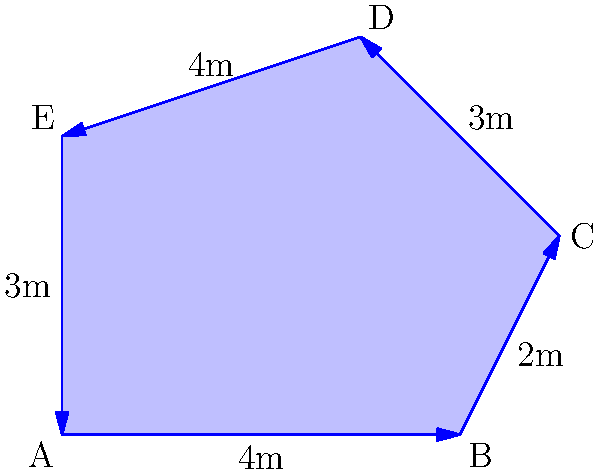The Bayleigh Chase grounds feature an irregularly shaped pond as shown in the diagram. The pond's perimeter is formed by five straight edges with lengths of 4m, 2m, 3m, 4m, and 3m. What is the area of this pond in square meters? To find the area of this irregular polygon, we can use the following steps:

1. Divide the polygon into triangles.
2. Calculate the area of each triangle.
3. Sum up the areas of all triangles.

Let's divide the polygon into three triangles: ABC, ACD, and ADE.

For triangle ABC:
Base = 4m, Height = 2m
Area of ABC = $\frac{1}{2} \times 4 \times 2 = 4$ sq m

For triangle ACD:
We can use Heron's formula: $A = \sqrt{s(s-a)(s-b)(s-c)}$
where $s = \frac{a+b+c}{2}$ (semi-perimeter)
$a = 4$, $b = 3$, $c = 5$ (using Pythagorean theorem for AC)
$s = \frac{4+3+5}{2} = 6$
Area of ACD = $\sqrt{6(6-4)(6-3)(6-5)} = \sqrt{6 \times 2 \times 3 \times 1} = \sqrt{36} = 6$ sq m

For triangle ADE:
Base = 3m, Height = 3m
Area of ADE = $\frac{1}{2} \times 3 \times 3 = 4.5$ sq m

Total area = Area of ABC + Area of ACD + Area of ADE
           = $4 + 6 + 4.5 = 14.5$ sq m
Answer: 14.5 sq m 